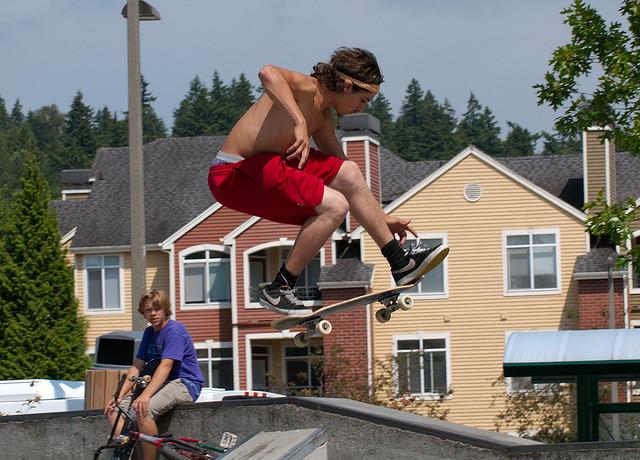What brand of sneakers is the skater wearing?
Answer briefly. Nike. Is the boy in the blue shirt admiring the skater's performance?
Write a very short answer. Yes. Can the boy really fly?
Be succinct. No. 